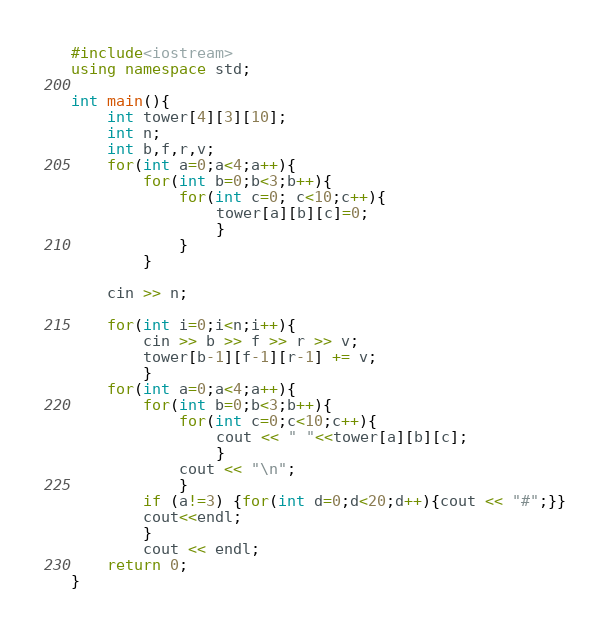Convert code to text. <code><loc_0><loc_0><loc_500><loc_500><_C++_>#include<iostream>
using namespace std;

int main(){
	int tower[4][3][10];
	int n;
	int b,f,r,v;
	for(int a=0;a<4;a++){
		for(int b=0;b<3;b++){
			for(int c=0; c<10;c++){
				tower[a][b][c]=0;
				}
			}
		}
		
	cin >> n;
	
	for(int i=0;i<n;i++){
		cin >> b >> f >> r >> v;
		tower[b-1][f-1][r-1] += v;
		}
	for(int a=0;a<4;a++){
		for(int b=0;b<3;b++){
			for(int c=0;c<10;c++){
				cout << " "<<tower[a][b][c];
				}
			cout << "\n";
			}
		if (a!=3) {for(int d=0;d<20;d++){cout << "#";}}
		cout<<endl;
		}
		cout << endl;
	return 0;
}</code> 